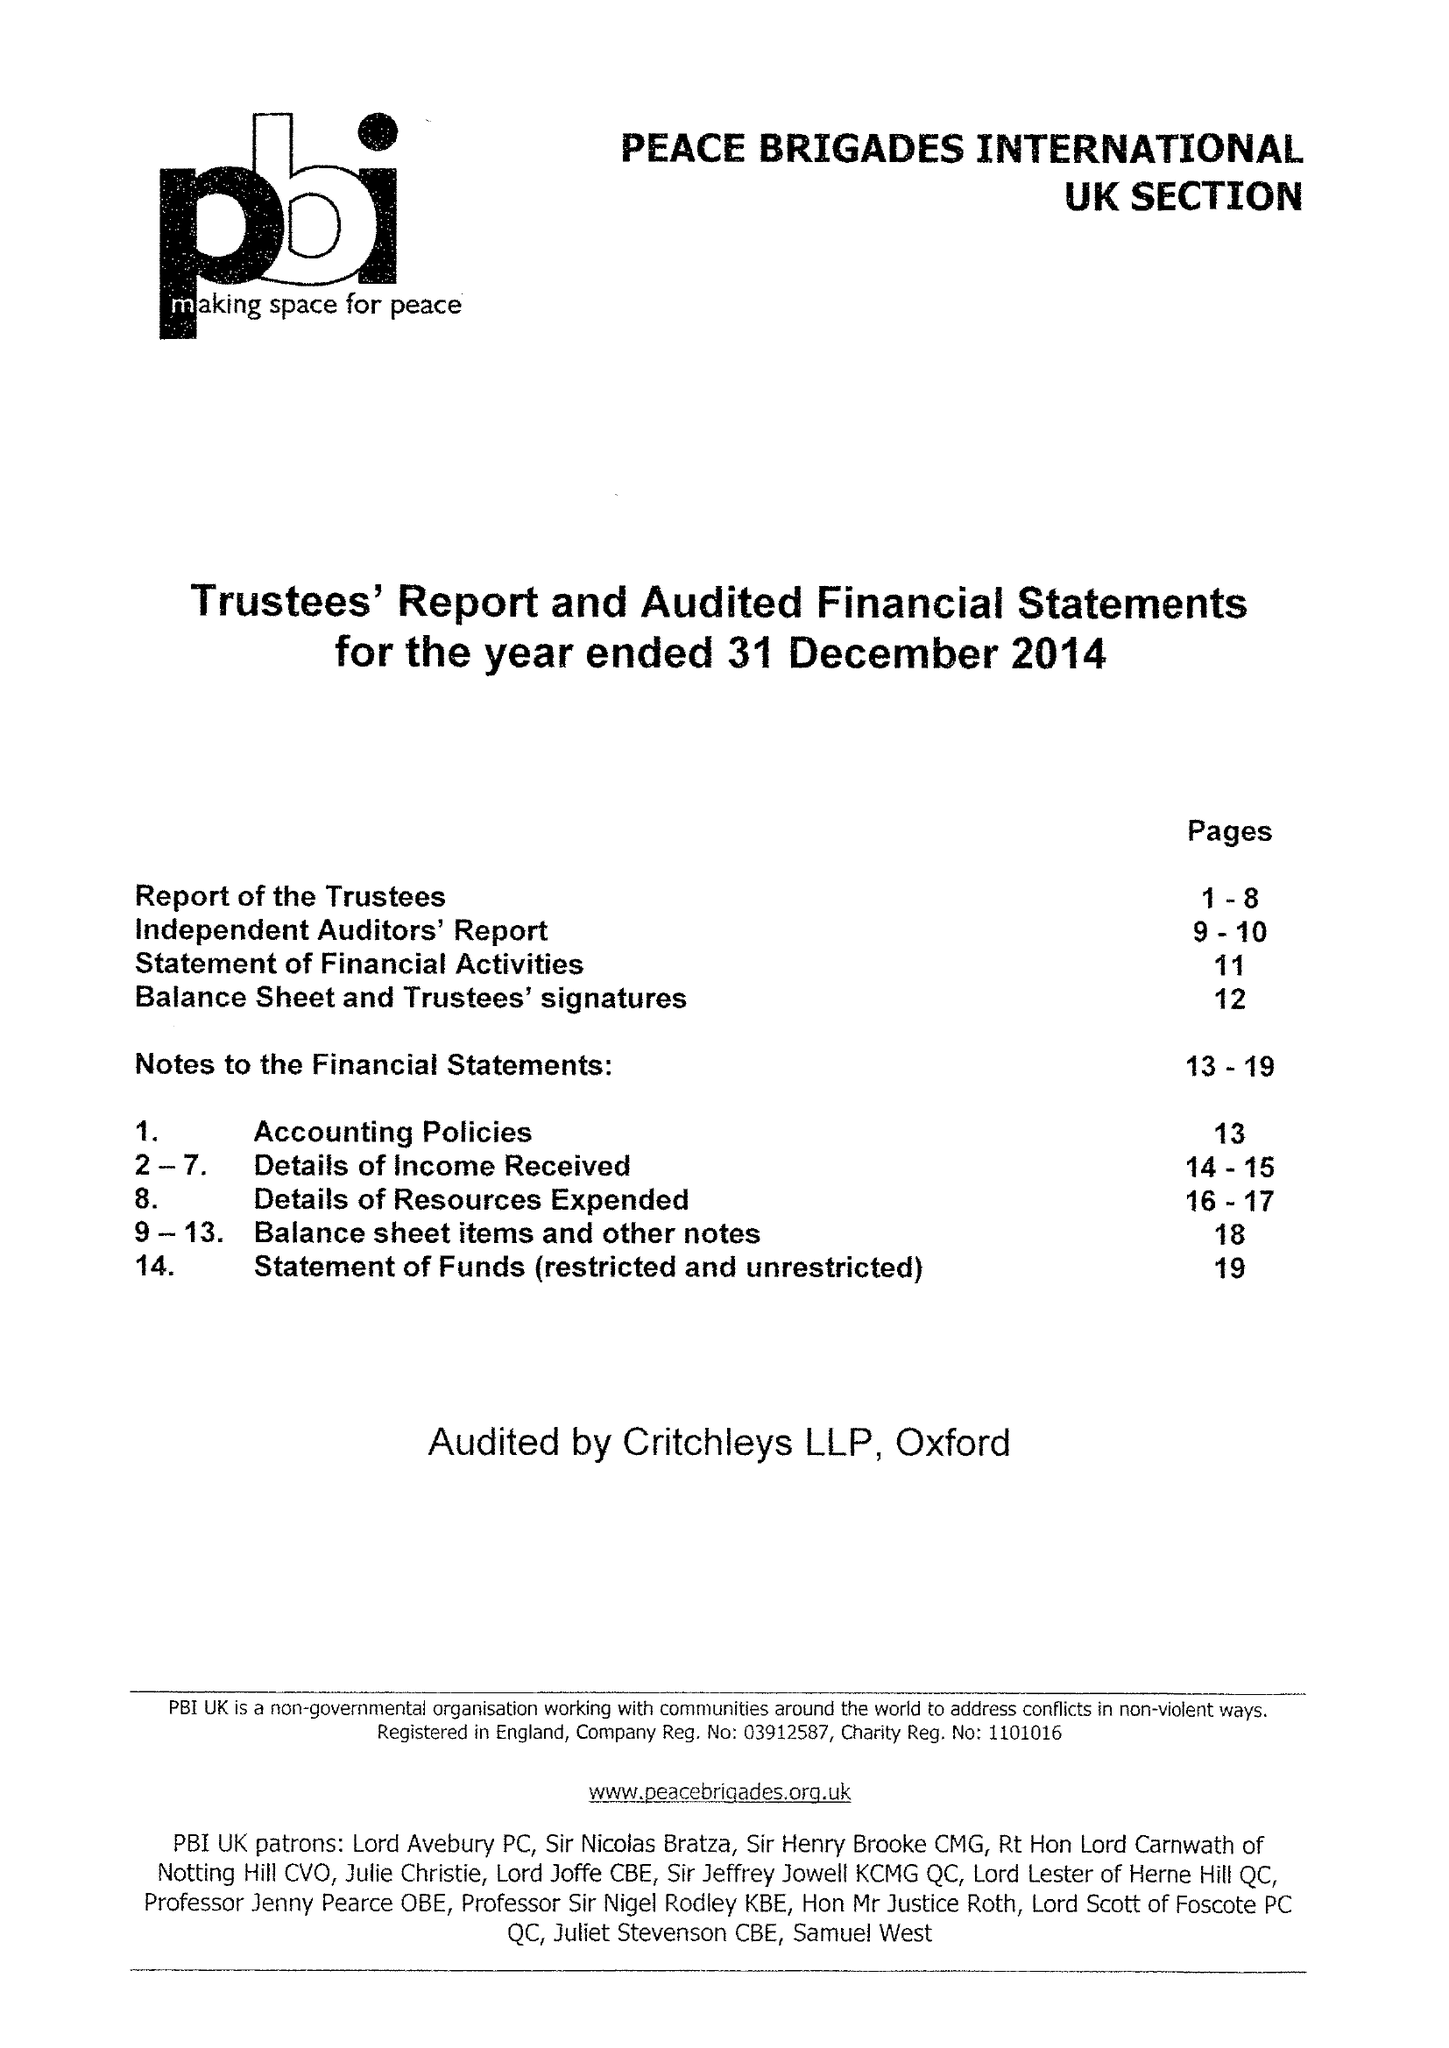What is the value for the address__postcode?
Answer the question using a single word or phrase. N19 5NJ 